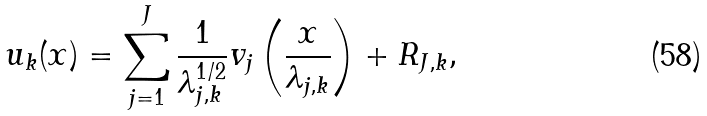<formula> <loc_0><loc_0><loc_500><loc_500>u _ { k } ( x ) = \sum _ { j = 1 } ^ { J } \frac { 1 } { \lambda _ { j , k } ^ { 1 / 2 } } v _ { j } \left ( \frac { x } { \lambda _ { j , k } } \right ) + R _ { J , k } ,</formula> 